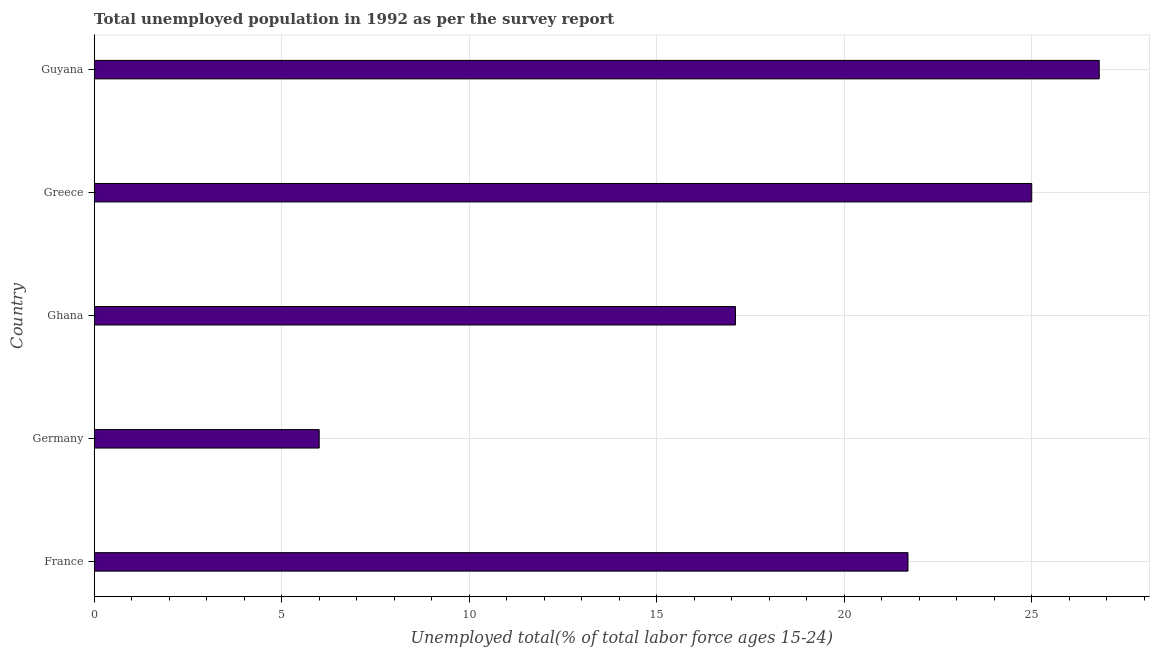Does the graph contain any zero values?
Make the answer very short. No. What is the title of the graph?
Keep it short and to the point. Total unemployed population in 1992 as per the survey report. What is the label or title of the X-axis?
Provide a succinct answer. Unemployed total(% of total labor force ages 15-24). Across all countries, what is the maximum unemployed youth?
Give a very brief answer. 26.8. Across all countries, what is the minimum unemployed youth?
Provide a short and direct response. 6. In which country was the unemployed youth maximum?
Your answer should be very brief. Guyana. In which country was the unemployed youth minimum?
Make the answer very short. Germany. What is the sum of the unemployed youth?
Make the answer very short. 96.6. What is the difference between the unemployed youth in Ghana and Greece?
Give a very brief answer. -7.9. What is the average unemployed youth per country?
Your answer should be very brief. 19.32. What is the median unemployed youth?
Provide a succinct answer. 21.7. In how many countries, is the unemployed youth greater than 4 %?
Offer a very short reply. 5. What is the ratio of the unemployed youth in Greece to that in Guyana?
Give a very brief answer. 0.93. What is the difference between the highest and the second highest unemployed youth?
Make the answer very short. 1.8. Is the sum of the unemployed youth in France and Ghana greater than the maximum unemployed youth across all countries?
Your answer should be compact. Yes. What is the difference between the highest and the lowest unemployed youth?
Give a very brief answer. 20.8. In how many countries, is the unemployed youth greater than the average unemployed youth taken over all countries?
Your answer should be very brief. 3. What is the difference between two consecutive major ticks on the X-axis?
Give a very brief answer. 5. What is the Unemployed total(% of total labor force ages 15-24) in France?
Provide a succinct answer. 21.7. What is the Unemployed total(% of total labor force ages 15-24) in Ghana?
Provide a succinct answer. 17.1. What is the Unemployed total(% of total labor force ages 15-24) in Greece?
Provide a short and direct response. 25. What is the Unemployed total(% of total labor force ages 15-24) in Guyana?
Offer a terse response. 26.8. What is the difference between the Unemployed total(% of total labor force ages 15-24) in France and Ghana?
Make the answer very short. 4.6. What is the difference between the Unemployed total(% of total labor force ages 15-24) in France and Greece?
Your answer should be compact. -3.3. What is the difference between the Unemployed total(% of total labor force ages 15-24) in France and Guyana?
Your response must be concise. -5.1. What is the difference between the Unemployed total(% of total labor force ages 15-24) in Germany and Ghana?
Provide a short and direct response. -11.1. What is the difference between the Unemployed total(% of total labor force ages 15-24) in Germany and Guyana?
Make the answer very short. -20.8. What is the difference between the Unemployed total(% of total labor force ages 15-24) in Ghana and Greece?
Ensure brevity in your answer.  -7.9. What is the difference between the Unemployed total(% of total labor force ages 15-24) in Ghana and Guyana?
Provide a short and direct response. -9.7. What is the ratio of the Unemployed total(% of total labor force ages 15-24) in France to that in Germany?
Keep it short and to the point. 3.62. What is the ratio of the Unemployed total(% of total labor force ages 15-24) in France to that in Ghana?
Make the answer very short. 1.27. What is the ratio of the Unemployed total(% of total labor force ages 15-24) in France to that in Greece?
Ensure brevity in your answer.  0.87. What is the ratio of the Unemployed total(% of total labor force ages 15-24) in France to that in Guyana?
Keep it short and to the point. 0.81. What is the ratio of the Unemployed total(% of total labor force ages 15-24) in Germany to that in Ghana?
Ensure brevity in your answer.  0.35. What is the ratio of the Unemployed total(% of total labor force ages 15-24) in Germany to that in Greece?
Provide a succinct answer. 0.24. What is the ratio of the Unemployed total(% of total labor force ages 15-24) in Germany to that in Guyana?
Your response must be concise. 0.22. What is the ratio of the Unemployed total(% of total labor force ages 15-24) in Ghana to that in Greece?
Your response must be concise. 0.68. What is the ratio of the Unemployed total(% of total labor force ages 15-24) in Ghana to that in Guyana?
Offer a terse response. 0.64. What is the ratio of the Unemployed total(% of total labor force ages 15-24) in Greece to that in Guyana?
Give a very brief answer. 0.93. 